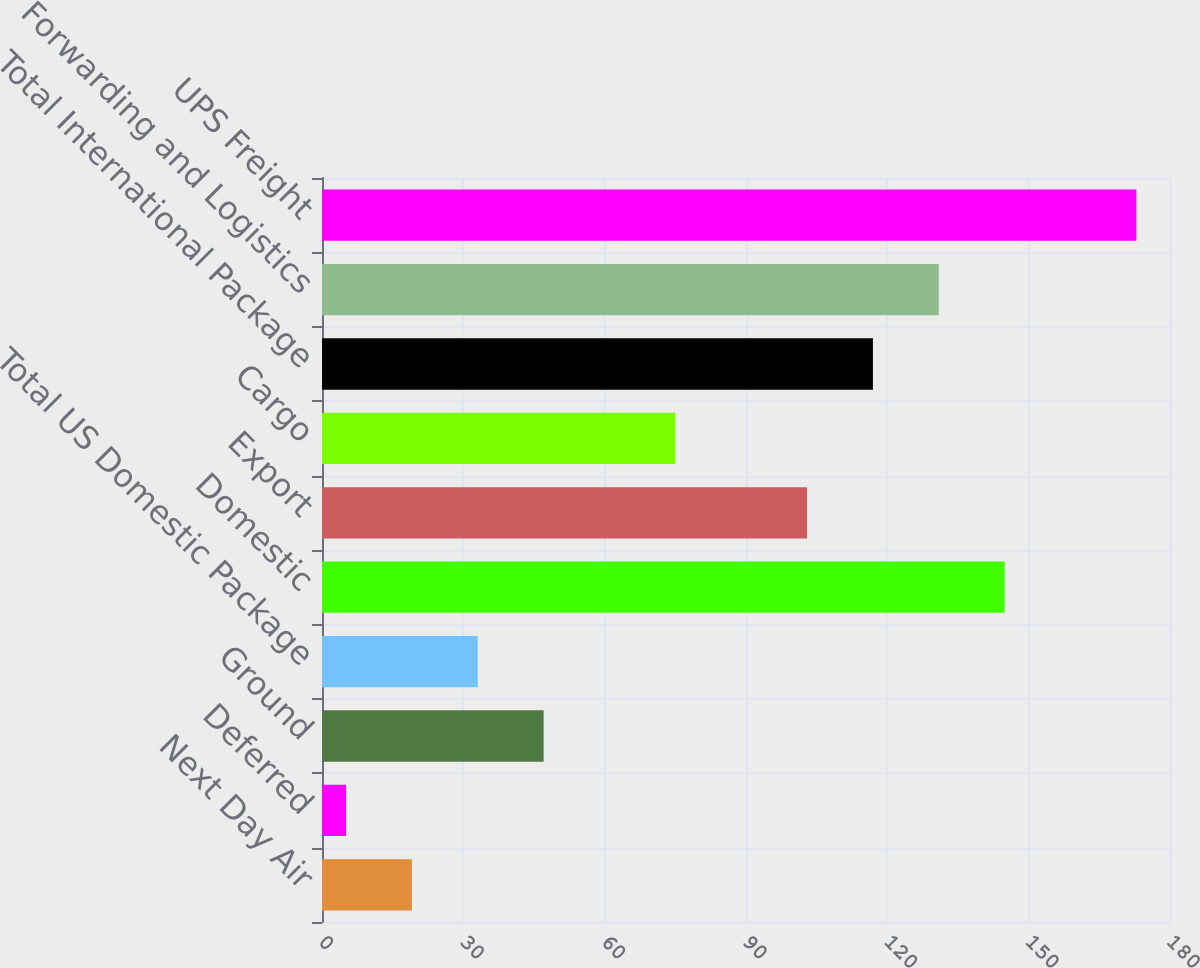Convert chart to OTSL. <chart><loc_0><loc_0><loc_500><loc_500><bar_chart><fcel>Next Day Air<fcel>Deferred<fcel>Ground<fcel>Total US Domestic Package<fcel>Domestic<fcel>Export<fcel>Cargo<fcel>Total International Package<fcel>Forwarding and Logistics<fcel>UPS Freight<nl><fcel>19.08<fcel>5.1<fcel>47.04<fcel>33.06<fcel>144.9<fcel>102.96<fcel>75<fcel>116.94<fcel>130.92<fcel>172.86<nl></chart> 